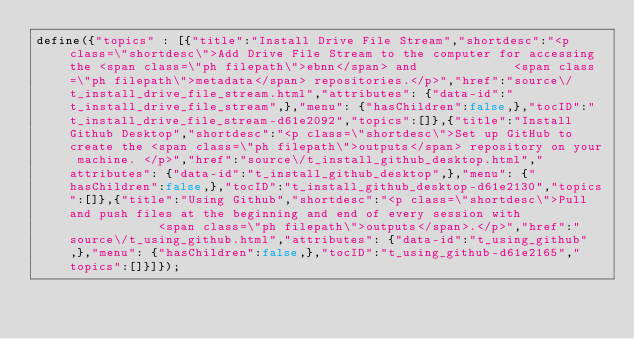<code> <loc_0><loc_0><loc_500><loc_500><_JavaScript_>define({"topics" : [{"title":"Install Drive File Stream","shortdesc":"<p class=\"shortdesc\">Add Drive File Stream to the computer for accessing the <span class=\"ph filepath\">ebnn</span> and             <span class=\"ph filepath\">metadata</span> repositories.</p>","href":"source\/t_install_drive_file_stream.html","attributes": {"data-id":"t_install_drive_file_stream",},"menu": {"hasChildren":false,},"tocID":"t_install_drive_file_stream-d61e2092","topics":[]},{"title":"Install Github Desktop","shortdesc":"<p class=\"shortdesc\">Set up GitHub to create the <span class=\"ph filepath\">outputs</span> repository on your machine. </p>","href":"source\/t_install_github_desktop.html","attributes": {"data-id":"t_install_github_desktop",},"menu": {"hasChildren":false,},"tocID":"t_install_github_desktop-d61e2130","topics":[]},{"title":"Using Github","shortdesc":"<p class=\"shortdesc\">Pull and push files at the beginning and end of every session with             <span class=\"ph filepath\">outputs</span>.</p>","href":"source\/t_using_github.html","attributes": {"data-id":"t_using_github",},"menu": {"hasChildren":false,},"tocID":"t_using_github-d61e2165","topics":[]}]});</code> 